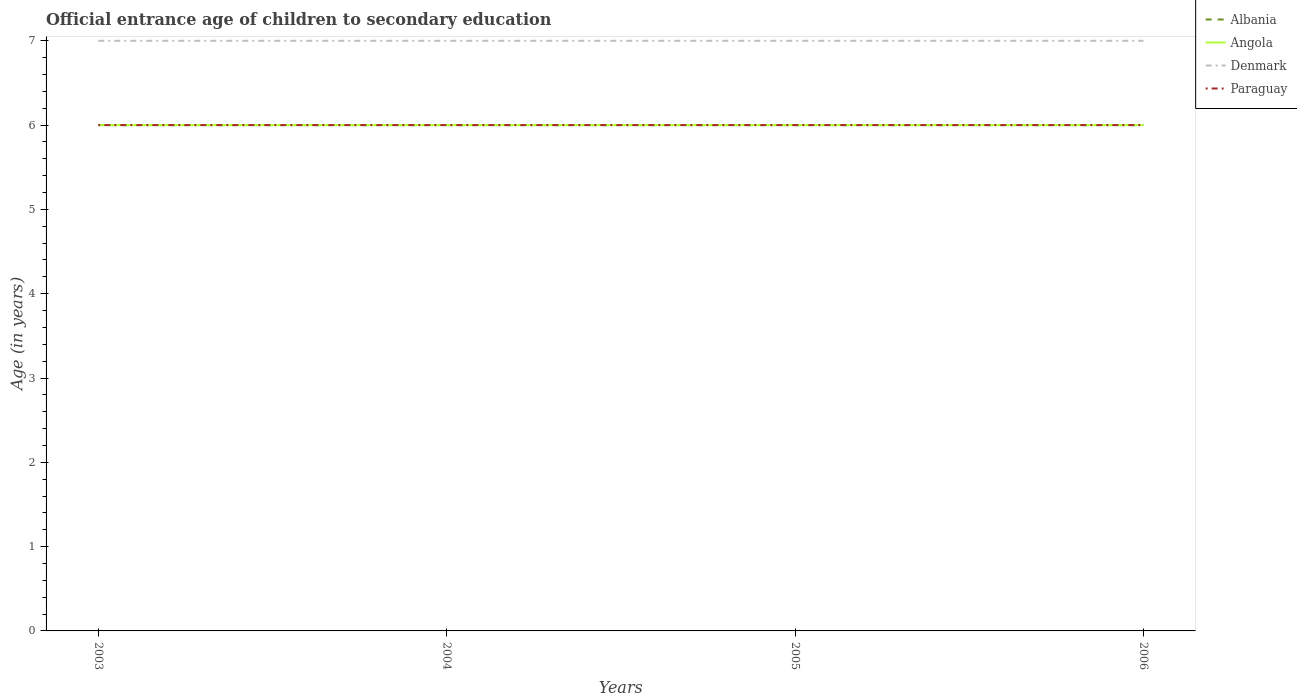In which year was the secondary school starting age of children in Denmark maximum?
Offer a very short reply. 2003. What is the difference between the highest and the second highest secondary school starting age of children in Angola?
Provide a short and direct response. 0. What is the difference between the highest and the lowest secondary school starting age of children in Angola?
Give a very brief answer. 0. Is the secondary school starting age of children in Angola strictly greater than the secondary school starting age of children in Denmark over the years?
Give a very brief answer. Yes. How many years are there in the graph?
Provide a succinct answer. 4. What is the difference between two consecutive major ticks on the Y-axis?
Keep it short and to the point. 1. Are the values on the major ticks of Y-axis written in scientific E-notation?
Provide a short and direct response. No. Does the graph contain any zero values?
Your answer should be compact. No. Does the graph contain grids?
Ensure brevity in your answer.  No. How are the legend labels stacked?
Your response must be concise. Vertical. What is the title of the graph?
Your response must be concise. Official entrance age of children to secondary education. Does "High income" appear as one of the legend labels in the graph?
Provide a succinct answer. No. What is the label or title of the Y-axis?
Your answer should be compact. Age (in years). What is the Age (in years) of Angola in 2003?
Make the answer very short. 6. What is the Age (in years) of Albania in 2004?
Offer a terse response. 6. What is the Age (in years) in Angola in 2004?
Provide a succinct answer. 6. What is the Age (in years) in Denmark in 2004?
Give a very brief answer. 7. What is the Age (in years) in Paraguay in 2004?
Give a very brief answer. 6. What is the Age (in years) of Albania in 2005?
Offer a terse response. 6. What is the Age (in years) in Angola in 2005?
Offer a terse response. 6. What is the Age (in years) in Paraguay in 2005?
Give a very brief answer. 6. What is the Age (in years) of Denmark in 2006?
Give a very brief answer. 7. Across all years, what is the maximum Age (in years) of Denmark?
Provide a succinct answer. 7. Across all years, what is the maximum Age (in years) in Paraguay?
Your answer should be compact. 6. Across all years, what is the minimum Age (in years) in Albania?
Offer a terse response. 6. Across all years, what is the minimum Age (in years) in Angola?
Offer a very short reply. 6. Across all years, what is the minimum Age (in years) of Paraguay?
Keep it short and to the point. 6. What is the total Age (in years) of Denmark in the graph?
Keep it short and to the point. 28. What is the difference between the Age (in years) of Albania in 2003 and that in 2004?
Keep it short and to the point. 0. What is the difference between the Age (in years) of Paraguay in 2003 and that in 2004?
Provide a short and direct response. 0. What is the difference between the Age (in years) in Albania in 2003 and that in 2005?
Your answer should be very brief. 0. What is the difference between the Age (in years) of Paraguay in 2003 and that in 2005?
Keep it short and to the point. 0. What is the difference between the Age (in years) of Denmark in 2003 and that in 2006?
Your answer should be compact. 0. What is the difference between the Age (in years) of Albania in 2004 and that in 2005?
Ensure brevity in your answer.  0. What is the difference between the Age (in years) of Paraguay in 2004 and that in 2005?
Keep it short and to the point. 0. What is the difference between the Age (in years) in Albania in 2004 and that in 2006?
Make the answer very short. 0. What is the difference between the Age (in years) of Albania in 2005 and that in 2006?
Provide a succinct answer. 0. What is the difference between the Age (in years) of Denmark in 2005 and that in 2006?
Your answer should be compact. 0. What is the difference between the Age (in years) in Paraguay in 2005 and that in 2006?
Offer a terse response. 0. What is the difference between the Age (in years) in Albania in 2003 and the Age (in years) in Angola in 2004?
Keep it short and to the point. 0. What is the difference between the Age (in years) of Albania in 2003 and the Age (in years) of Denmark in 2004?
Your answer should be very brief. -1. What is the difference between the Age (in years) in Angola in 2003 and the Age (in years) in Paraguay in 2004?
Provide a short and direct response. 0. What is the difference between the Age (in years) in Albania in 2003 and the Age (in years) in Angola in 2005?
Make the answer very short. 0. What is the difference between the Age (in years) of Albania in 2003 and the Age (in years) of Denmark in 2005?
Provide a succinct answer. -1. What is the difference between the Age (in years) in Albania in 2003 and the Age (in years) in Paraguay in 2005?
Provide a short and direct response. 0. What is the difference between the Age (in years) in Denmark in 2003 and the Age (in years) in Paraguay in 2005?
Ensure brevity in your answer.  1. What is the difference between the Age (in years) of Albania in 2003 and the Age (in years) of Denmark in 2006?
Ensure brevity in your answer.  -1. What is the difference between the Age (in years) of Angola in 2003 and the Age (in years) of Denmark in 2006?
Keep it short and to the point. -1. What is the difference between the Age (in years) in Albania in 2004 and the Age (in years) in Denmark in 2005?
Your answer should be very brief. -1. What is the difference between the Age (in years) in Angola in 2004 and the Age (in years) in Denmark in 2005?
Provide a succinct answer. -1. What is the difference between the Age (in years) of Angola in 2004 and the Age (in years) of Paraguay in 2005?
Ensure brevity in your answer.  0. What is the difference between the Age (in years) of Denmark in 2004 and the Age (in years) of Paraguay in 2005?
Your answer should be compact. 1. What is the difference between the Age (in years) of Albania in 2004 and the Age (in years) of Denmark in 2006?
Keep it short and to the point. -1. What is the difference between the Age (in years) of Angola in 2004 and the Age (in years) of Denmark in 2006?
Keep it short and to the point. -1. What is the difference between the Age (in years) in Angola in 2004 and the Age (in years) in Paraguay in 2006?
Your answer should be compact. 0. What is the difference between the Age (in years) of Albania in 2005 and the Age (in years) of Paraguay in 2006?
Your answer should be very brief. 0. What is the difference between the Age (in years) in Angola in 2005 and the Age (in years) in Denmark in 2006?
Give a very brief answer. -1. What is the difference between the Age (in years) of Angola in 2005 and the Age (in years) of Paraguay in 2006?
Your answer should be very brief. 0. What is the average Age (in years) of Albania per year?
Make the answer very short. 6. What is the average Age (in years) in Angola per year?
Offer a terse response. 6. What is the average Age (in years) of Denmark per year?
Provide a short and direct response. 7. In the year 2003, what is the difference between the Age (in years) in Albania and Age (in years) in Denmark?
Offer a terse response. -1. In the year 2003, what is the difference between the Age (in years) of Denmark and Age (in years) of Paraguay?
Give a very brief answer. 1. In the year 2004, what is the difference between the Age (in years) of Albania and Age (in years) of Angola?
Your response must be concise. 0. In the year 2004, what is the difference between the Age (in years) of Angola and Age (in years) of Denmark?
Give a very brief answer. -1. In the year 2004, what is the difference between the Age (in years) of Angola and Age (in years) of Paraguay?
Make the answer very short. 0. In the year 2005, what is the difference between the Age (in years) of Albania and Age (in years) of Paraguay?
Provide a succinct answer. 0. In the year 2006, what is the difference between the Age (in years) in Angola and Age (in years) in Denmark?
Your response must be concise. -1. What is the ratio of the Age (in years) in Paraguay in 2003 to that in 2004?
Provide a succinct answer. 1. What is the ratio of the Age (in years) in Angola in 2003 to that in 2005?
Your response must be concise. 1. What is the ratio of the Age (in years) in Paraguay in 2003 to that in 2005?
Give a very brief answer. 1. What is the ratio of the Age (in years) of Albania in 2003 to that in 2006?
Offer a terse response. 1. What is the ratio of the Age (in years) in Angola in 2003 to that in 2006?
Make the answer very short. 1. What is the ratio of the Age (in years) of Albania in 2004 to that in 2005?
Give a very brief answer. 1. What is the ratio of the Age (in years) of Angola in 2004 to that in 2005?
Provide a short and direct response. 1. What is the ratio of the Age (in years) in Denmark in 2004 to that in 2005?
Ensure brevity in your answer.  1. What is the ratio of the Age (in years) of Paraguay in 2004 to that in 2005?
Keep it short and to the point. 1. What is the ratio of the Age (in years) of Albania in 2004 to that in 2006?
Keep it short and to the point. 1. What is the ratio of the Age (in years) of Angola in 2004 to that in 2006?
Provide a short and direct response. 1. What is the ratio of the Age (in years) of Denmark in 2004 to that in 2006?
Your answer should be very brief. 1. What is the ratio of the Age (in years) in Paraguay in 2004 to that in 2006?
Your response must be concise. 1. What is the ratio of the Age (in years) of Denmark in 2005 to that in 2006?
Your answer should be compact. 1. What is the difference between the highest and the second highest Age (in years) in Angola?
Your response must be concise. 0. What is the difference between the highest and the second highest Age (in years) of Paraguay?
Your response must be concise. 0. What is the difference between the highest and the lowest Age (in years) of Albania?
Ensure brevity in your answer.  0. What is the difference between the highest and the lowest Age (in years) of Denmark?
Give a very brief answer. 0. What is the difference between the highest and the lowest Age (in years) in Paraguay?
Your answer should be compact. 0. 